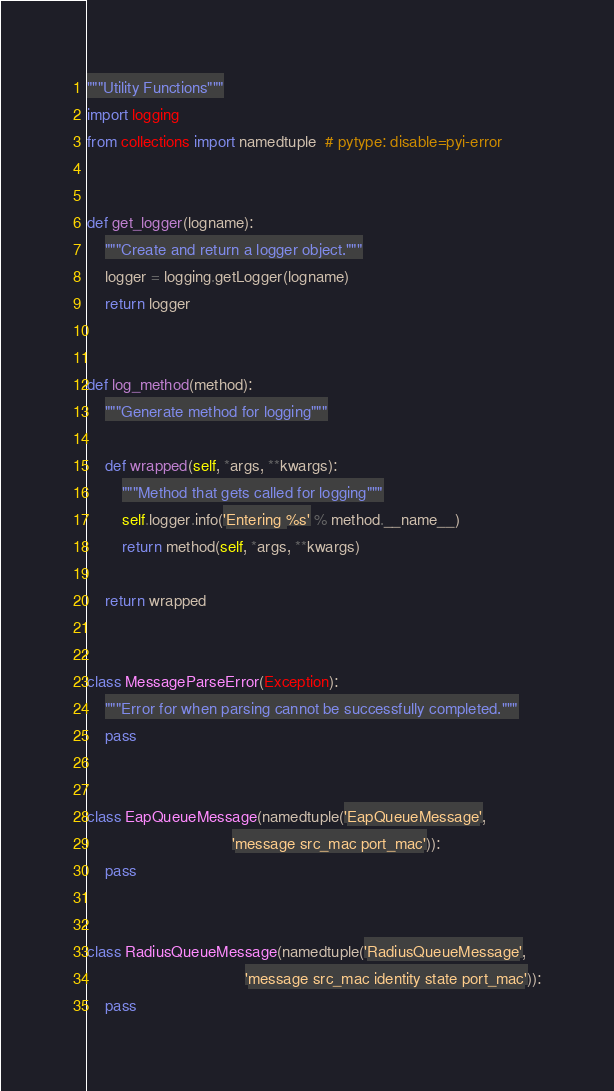<code> <loc_0><loc_0><loc_500><loc_500><_Python_>"""Utility Functions"""
import logging
from collections import namedtuple  # pytype: disable=pyi-error


def get_logger(logname):
    """Create and return a logger object."""
    logger = logging.getLogger(logname)
    return logger


def log_method(method):
    """Generate method for logging"""

    def wrapped(self, *args, **kwargs):
        """Method that gets called for logging"""
        self.logger.info('Entering %s' % method.__name__)
        return method(self, *args, **kwargs)

    return wrapped


class MessageParseError(Exception):
    """Error for when parsing cannot be successfully completed."""
    pass


class EapQueueMessage(namedtuple('EapQueueMessage',
                                 'message src_mac port_mac')):
    pass


class RadiusQueueMessage(namedtuple('RadiusQueueMessage',
                                    'message src_mac identity state port_mac')):
    pass
</code> 